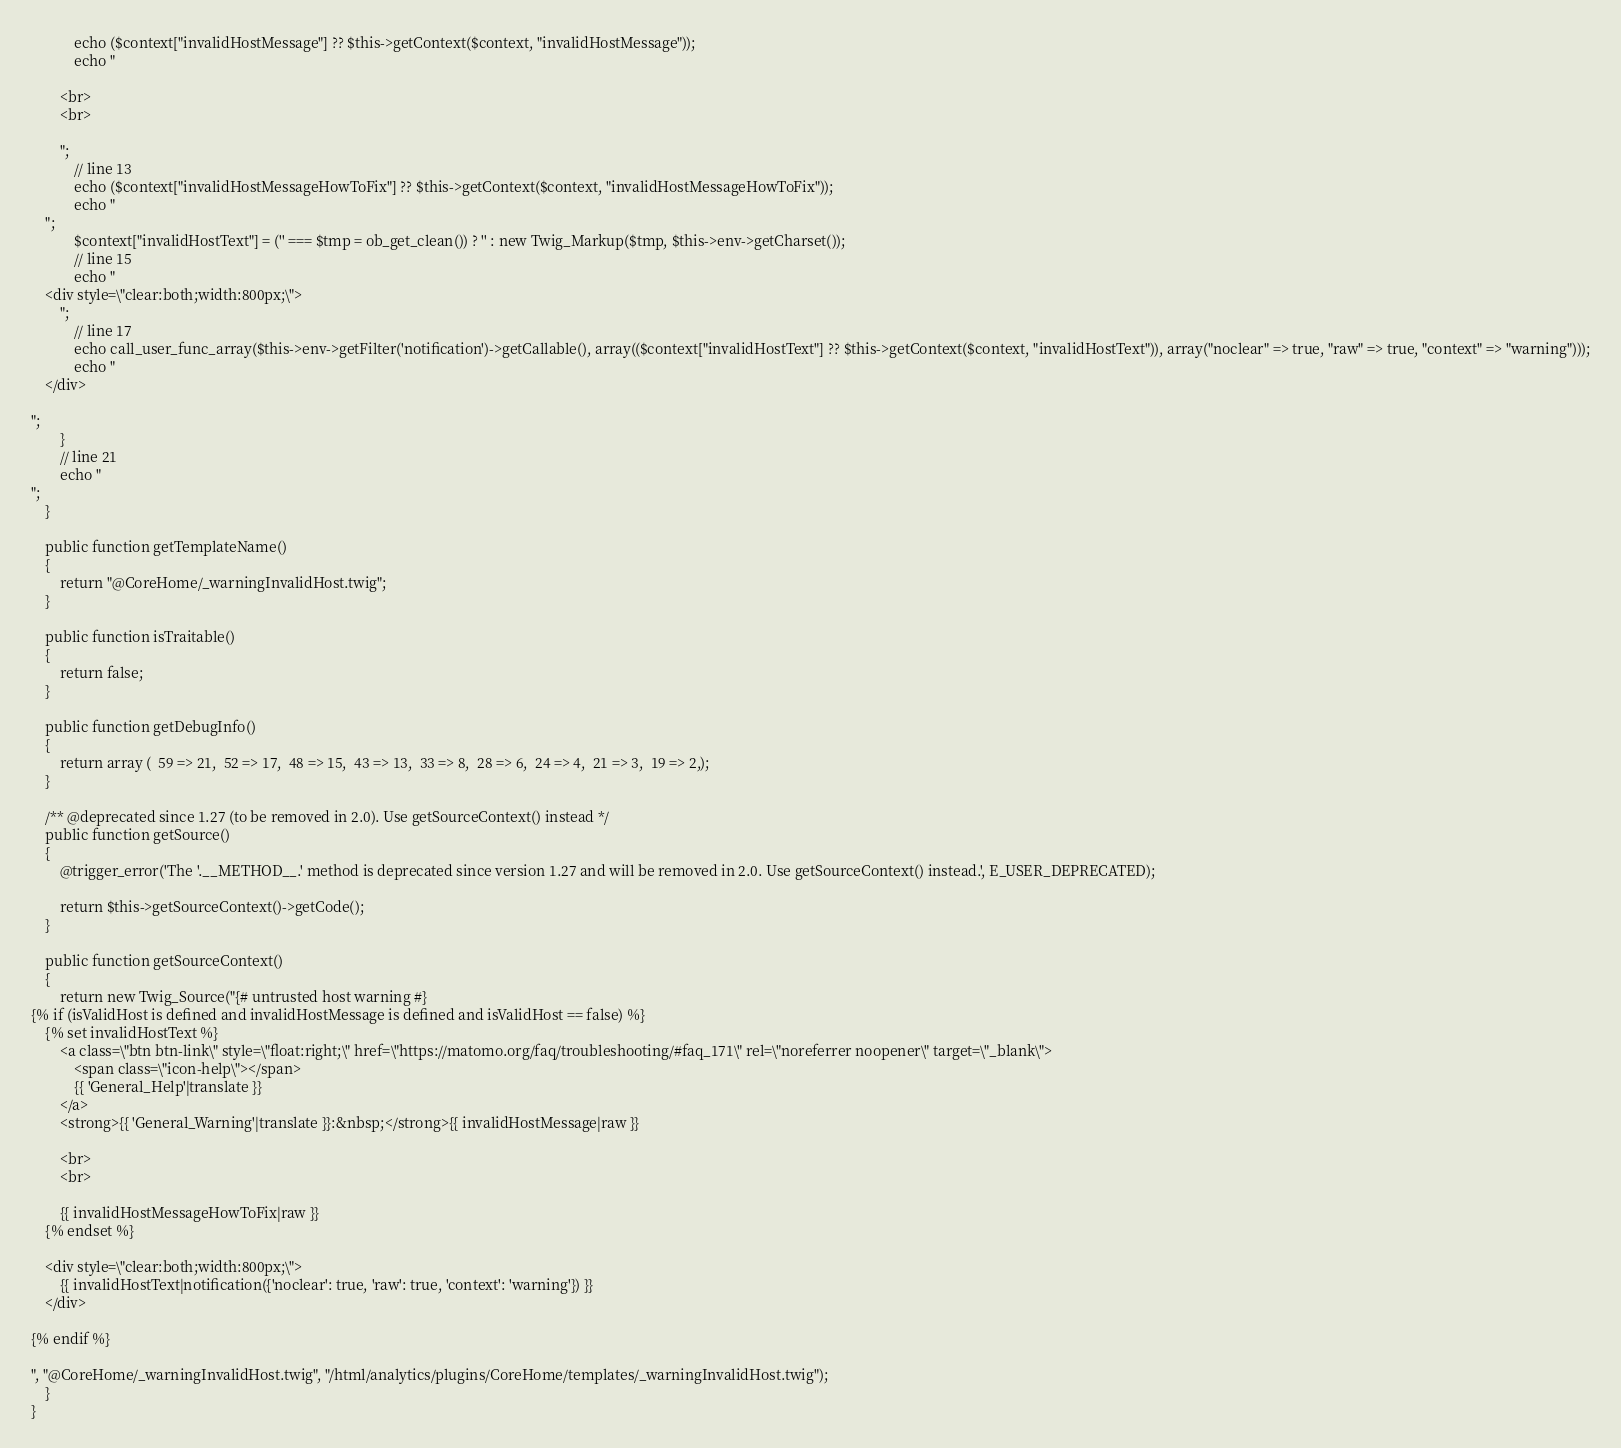Convert code to text. <code><loc_0><loc_0><loc_500><loc_500><_PHP_>            echo ($context["invalidHostMessage"] ?? $this->getContext($context, "invalidHostMessage"));
            echo "

        <br>
        <br>

        ";
            // line 13
            echo ($context["invalidHostMessageHowToFix"] ?? $this->getContext($context, "invalidHostMessageHowToFix"));
            echo "
    ";
            $context["invalidHostText"] = ('' === $tmp = ob_get_clean()) ? '' : new Twig_Markup($tmp, $this->env->getCharset());
            // line 15
            echo "
    <div style=\"clear:both;width:800px;\">
        ";
            // line 17
            echo call_user_func_array($this->env->getFilter('notification')->getCallable(), array(($context["invalidHostText"] ?? $this->getContext($context, "invalidHostText")), array("noclear" => true, "raw" => true, "context" => "warning")));
            echo "
    </div>

";
        }
        // line 21
        echo "
";
    }

    public function getTemplateName()
    {
        return "@CoreHome/_warningInvalidHost.twig";
    }

    public function isTraitable()
    {
        return false;
    }

    public function getDebugInfo()
    {
        return array (  59 => 21,  52 => 17,  48 => 15,  43 => 13,  33 => 8,  28 => 6,  24 => 4,  21 => 3,  19 => 2,);
    }

    /** @deprecated since 1.27 (to be removed in 2.0). Use getSourceContext() instead */
    public function getSource()
    {
        @trigger_error('The '.__METHOD__.' method is deprecated since version 1.27 and will be removed in 2.0. Use getSourceContext() instead.', E_USER_DEPRECATED);

        return $this->getSourceContext()->getCode();
    }

    public function getSourceContext()
    {
        return new Twig_Source("{# untrusted host warning #}
{% if (isValidHost is defined and invalidHostMessage is defined and isValidHost == false) %}
    {% set invalidHostText %}
        <a class=\"btn btn-link\" style=\"float:right;\" href=\"https://matomo.org/faq/troubleshooting/#faq_171\" rel=\"noreferrer noopener\" target=\"_blank\">
            <span class=\"icon-help\"></span>
            {{ 'General_Help'|translate }}
        </a>
        <strong>{{ 'General_Warning'|translate }}:&nbsp;</strong>{{ invalidHostMessage|raw }}

        <br>
        <br>

        {{ invalidHostMessageHowToFix|raw }}
    {% endset %}

    <div style=\"clear:both;width:800px;\">
        {{ invalidHostText|notification({'noclear': true, 'raw': true, 'context': 'warning'}) }}
    </div>

{% endif %}

", "@CoreHome/_warningInvalidHost.twig", "/html/analytics/plugins/CoreHome/templates/_warningInvalidHost.twig");
    }
}
</code> 